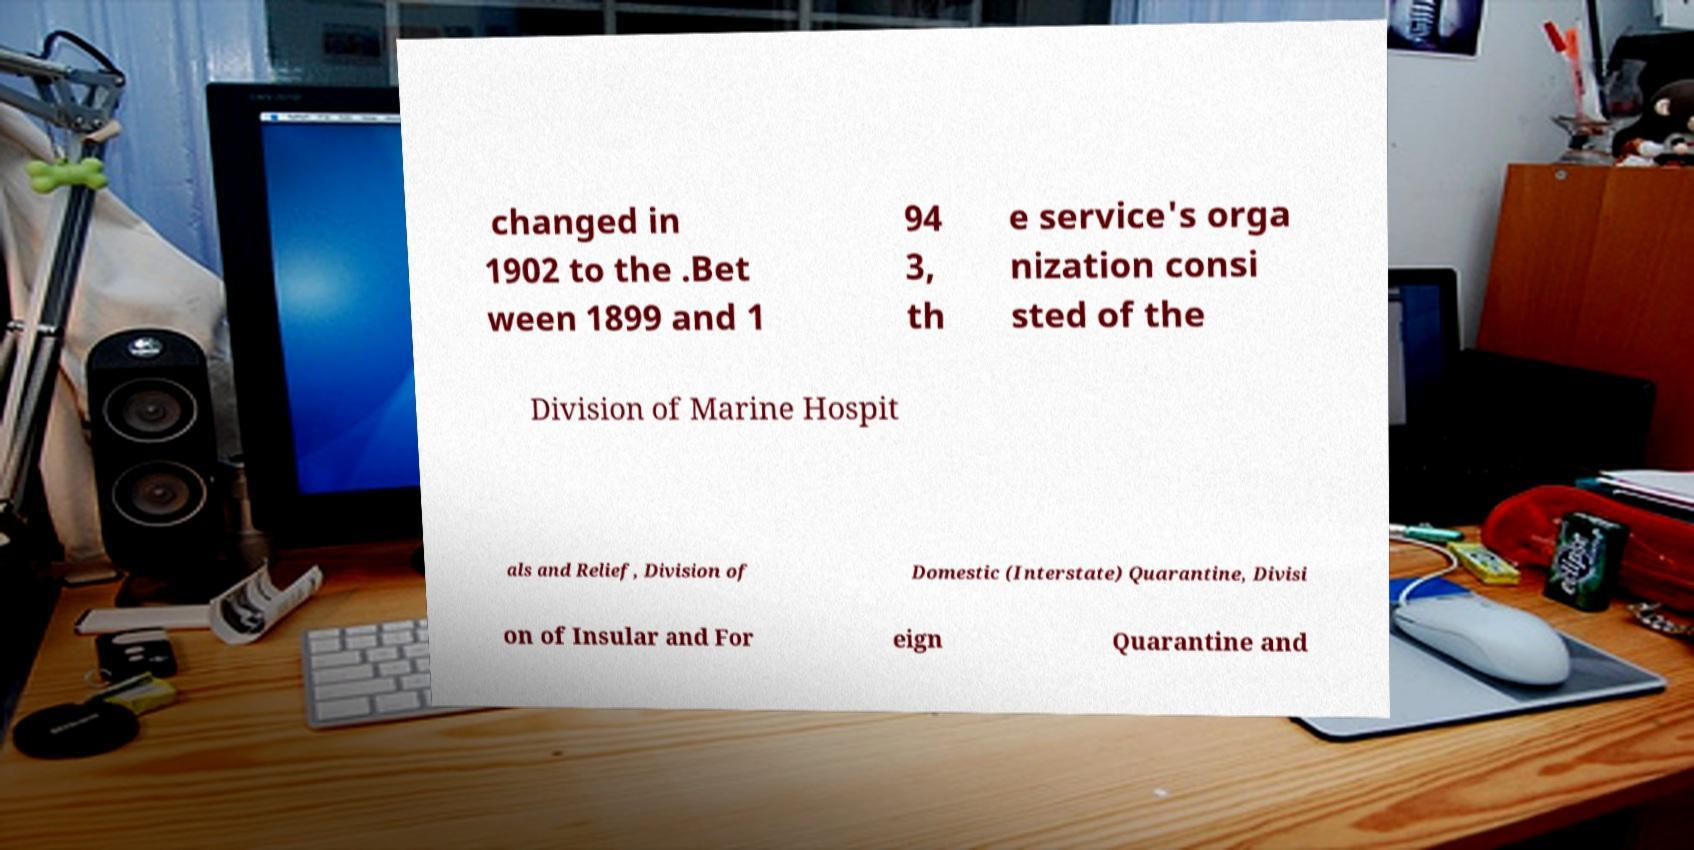Can you read and provide the text displayed in the image?This photo seems to have some interesting text. Can you extract and type it out for me? changed in 1902 to the .Bet ween 1899 and 1 94 3, th e service's orga nization consi sted of the Division of Marine Hospit als and Relief, Division of Domestic (Interstate) Quarantine, Divisi on of Insular and For eign Quarantine and 